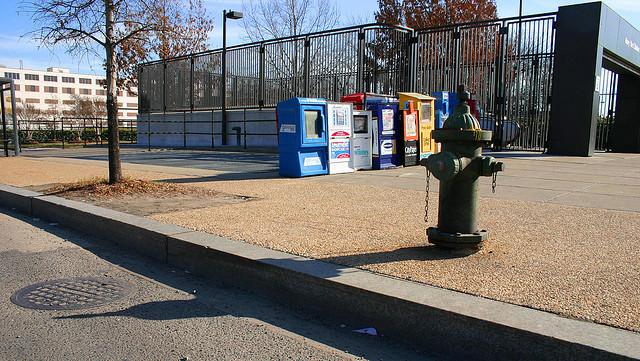Is this a busy sidewalk?
Answer briefly. No. Is this fire hydrant painted red?
Short answer required. No. Why are the newspaper boxes on the sidewalk?
Be succinct. For sale. 